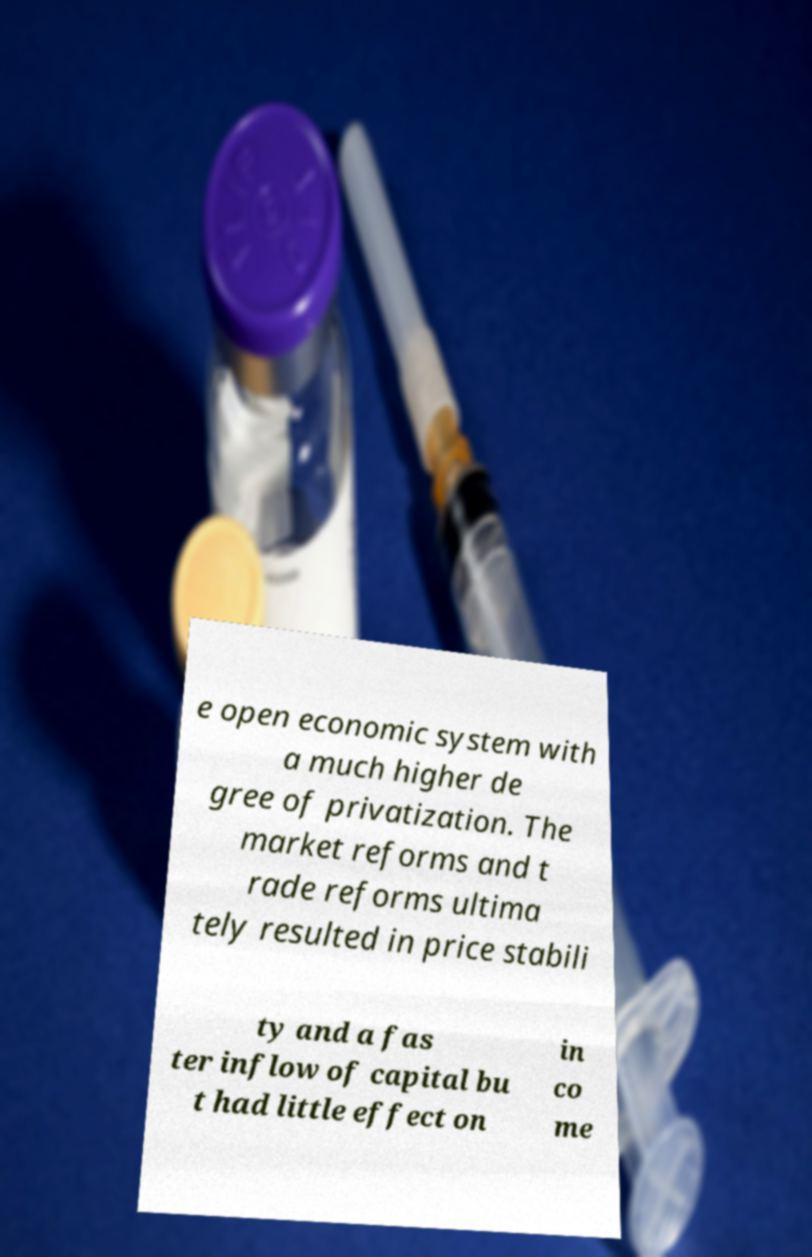What messages or text are displayed in this image? I need them in a readable, typed format. e open economic system with a much higher de gree of privatization. The market reforms and t rade reforms ultima tely resulted in price stabili ty and a fas ter inflow of capital bu t had little effect on in co me 